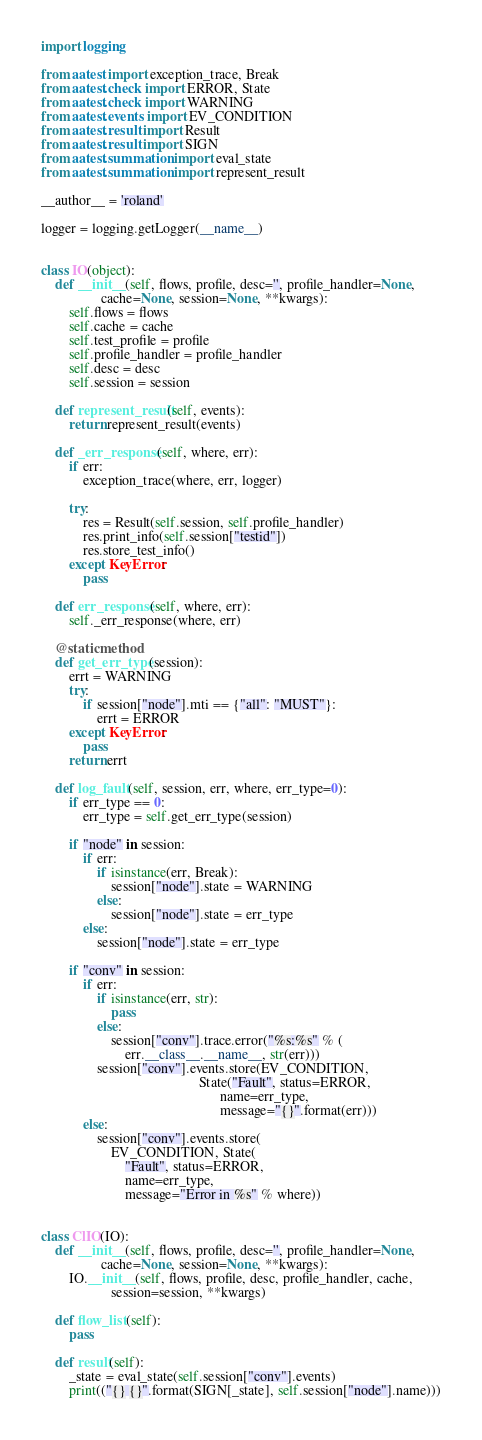Convert code to text. <code><loc_0><loc_0><loc_500><loc_500><_Python_>import logging

from aatest import exception_trace, Break
from aatest.check import ERROR, State
from aatest.check import WARNING
from aatest.events import EV_CONDITION
from aatest.result import Result
from aatest.result import SIGN
from aatest.summation import eval_state
from aatest.summation import represent_result

__author__ = 'roland'

logger = logging.getLogger(__name__)


class IO(object):
    def __init__(self, flows, profile, desc='', profile_handler=None,
                 cache=None, session=None, **kwargs):
        self.flows = flows
        self.cache = cache
        self.test_profile = profile
        self.profile_handler = profile_handler
        self.desc = desc
        self.session = session

    def represent_result(self, events):
        return represent_result(events)

    def _err_response(self, where, err):
        if err:
            exception_trace(where, err, logger)

        try:
            res = Result(self.session, self.profile_handler)
            res.print_info(self.session["testid"])
            res.store_test_info()
        except KeyError:
            pass

    def err_response(self, where, err):
        self._err_response(where, err)

    @staticmethod
    def get_err_type(session):
        errt = WARNING
        try:
            if session["node"].mti == {"all": "MUST"}:
                errt = ERROR
        except KeyError:
            pass
        return errt

    def log_fault(self, session, err, where, err_type=0):
        if err_type == 0:
            err_type = self.get_err_type(session)

        if "node" in session:
            if err:
                if isinstance(err, Break):
                    session["node"].state = WARNING
                else:
                    session["node"].state = err_type
            else:
                session["node"].state = err_type

        if "conv" in session:
            if err:
                if isinstance(err, str):
                    pass
                else:
                    session["conv"].trace.error("%s:%s" % (
                        err.__class__.__name__, str(err)))
                session["conv"].events.store(EV_CONDITION,
                                             State("Fault", status=ERROR,
                                                   name=err_type,
                                                   message="{}".format(err)))
            else:
                session["conv"].events.store(
                    EV_CONDITION, State(
                        "Fault", status=ERROR,
                        name=err_type,
                        message="Error in %s" % where))


class ClIO(IO):
    def __init__(self, flows, profile, desc='', profile_handler=None,
                 cache=None, session=None, **kwargs):
        IO.__init__(self, flows, profile, desc, profile_handler, cache,
                    session=session, **kwargs)

    def flow_list(self):
        pass

    def result(self):
        _state = eval_state(self.session["conv"].events)
        print(("{} {}".format(SIGN[_state], self.session["node"].name)))


</code> 